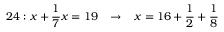Convert formula to latex. <formula><loc_0><loc_0><loc_500><loc_500>2 4 \colon x + { \frac { 1 } { 7 } } x = 1 9 \, \rightarrow \, x = 1 6 + { \frac { 1 } { 2 } } + { \frac { 1 } { 8 } }</formula> 